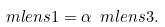<formula> <loc_0><loc_0><loc_500><loc_500>\ m l e n s { 1 } = \alpha \ m l e n s { 3 } .</formula> 